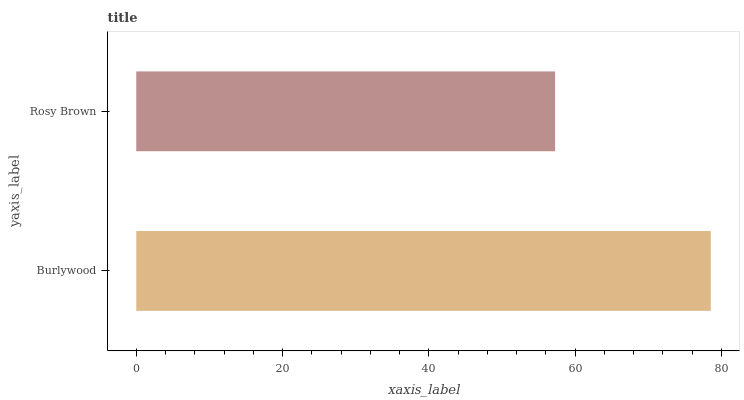Is Rosy Brown the minimum?
Answer yes or no. Yes. Is Burlywood the maximum?
Answer yes or no. Yes. Is Rosy Brown the maximum?
Answer yes or no. No. Is Burlywood greater than Rosy Brown?
Answer yes or no. Yes. Is Rosy Brown less than Burlywood?
Answer yes or no. Yes. Is Rosy Brown greater than Burlywood?
Answer yes or no. No. Is Burlywood less than Rosy Brown?
Answer yes or no. No. Is Burlywood the high median?
Answer yes or no. Yes. Is Rosy Brown the low median?
Answer yes or no. Yes. Is Rosy Brown the high median?
Answer yes or no. No. Is Burlywood the low median?
Answer yes or no. No. 